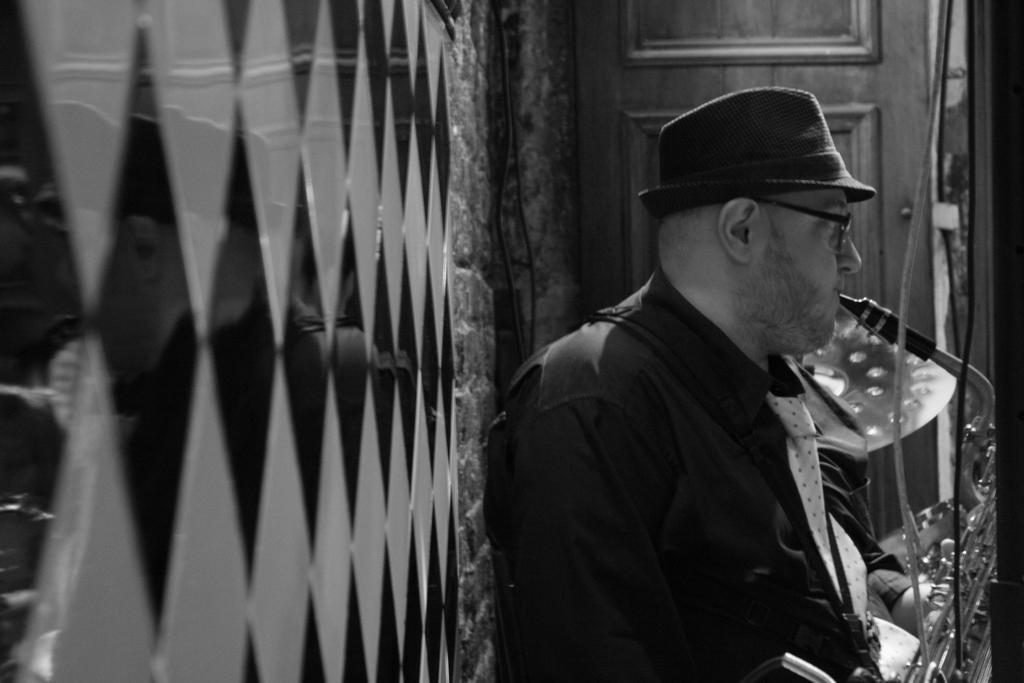Can you describe this image briefly? On the right side of the image we can see a man is holding a trumpet and wearing a hat. On the left side of the image wall is there. At the top of the image door is present. 